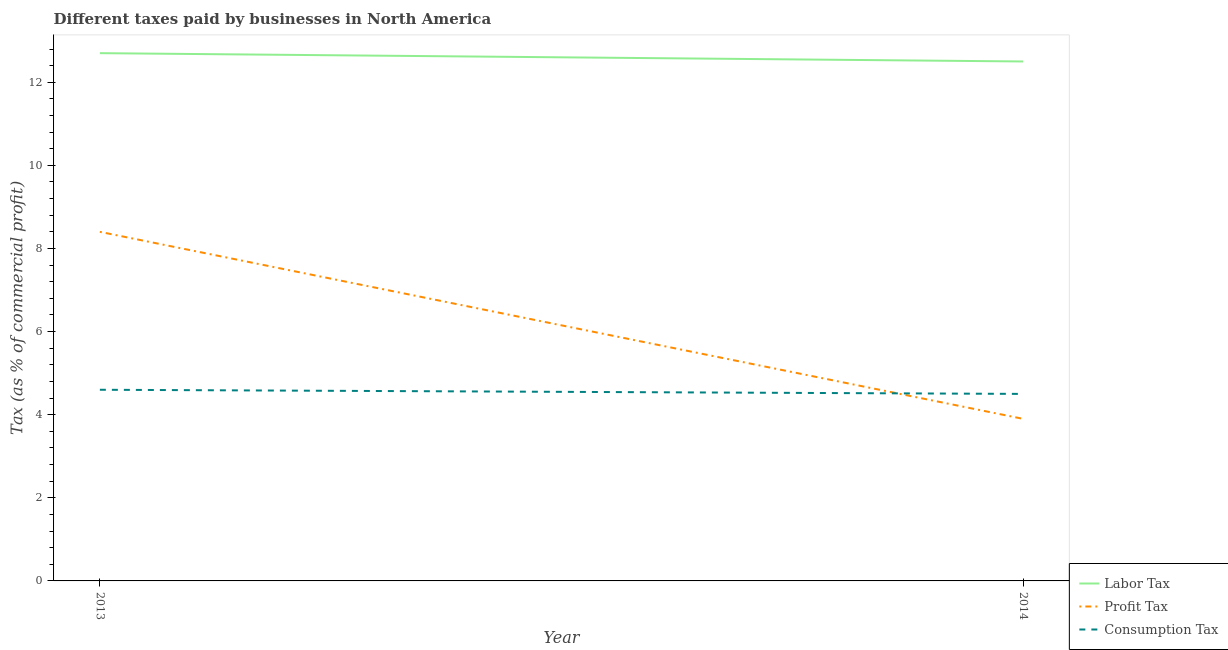How many different coloured lines are there?
Make the answer very short. 3. Does the line corresponding to percentage of profit tax intersect with the line corresponding to percentage of consumption tax?
Give a very brief answer. Yes. Is the number of lines equal to the number of legend labels?
Offer a very short reply. Yes. What is the percentage of profit tax in 2013?
Give a very brief answer. 8.4. In which year was the percentage of consumption tax maximum?
Give a very brief answer. 2013. In which year was the percentage of consumption tax minimum?
Provide a short and direct response. 2014. What is the total percentage of profit tax in the graph?
Your response must be concise. 12.3. What is the difference between the percentage of profit tax in 2013 and that in 2014?
Give a very brief answer. 4.5. What is the difference between the percentage of profit tax in 2013 and the percentage of labor tax in 2014?
Ensure brevity in your answer.  -4.1. What is the average percentage of labor tax per year?
Your response must be concise. 12.6. In the year 2014, what is the difference between the percentage of consumption tax and percentage of labor tax?
Give a very brief answer. -8. In how many years, is the percentage of profit tax greater than 1.6 %?
Ensure brevity in your answer.  2. What is the ratio of the percentage of labor tax in 2013 to that in 2014?
Provide a succinct answer. 1.02. In how many years, is the percentage of consumption tax greater than the average percentage of consumption tax taken over all years?
Offer a very short reply. 1. Is the percentage of profit tax strictly less than the percentage of consumption tax over the years?
Ensure brevity in your answer.  No. How many lines are there?
Your answer should be compact. 3. How many years are there in the graph?
Your answer should be compact. 2. What is the difference between two consecutive major ticks on the Y-axis?
Ensure brevity in your answer.  2. Where does the legend appear in the graph?
Offer a very short reply. Bottom right. How are the legend labels stacked?
Give a very brief answer. Vertical. What is the title of the graph?
Ensure brevity in your answer.  Different taxes paid by businesses in North America. Does "Negligence towards kids" appear as one of the legend labels in the graph?
Ensure brevity in your answer.  No. What is the label or title of the Y-axis?
Your answer should be very brief. Tax (as % of commercial profit). What is the Tax (as % of commercial profit) of Labor Tax in 2014?
Offer a very short reply. 12.5. What is the Tax (as % of commercial profit) in Profit Tax in 2014?
Offer a very short reply. 3.9. What is the Tax (as % of commercial profit) of Consumption Tax in 2014?
Offer a terse response. 4.5. Across all years, what is the maximum Tax (as % of commercial profit) of Labor Tax?
Give a very brief answer. 12.7. Across all years, what is the maximum Tax (as % of commercial profit) in Profit Tax?
Your response must be concise. 8.4. Across all years, what is the minimum Tax (as % of commercial profit) in Labor Tax?
Provide a succinct answer. 12.5. Across all years, what is the minimum Tax (as % of commercial profit) of Profit Tax?
Your answer should be very brief. 3.9. What is the total Tax (as % of commercial profit) of Labor Tax in the graph?
Your answer should be very brief. 25.2. What is the total Tax (as % of commercial profit) of Profit Tax in the graph?
Your response must be concise. 12.3. What is the total Tax (as % of commercial profit) of Consumption Tax in the graph?
Keep it short and to the point. 9.1. What is the difference between the Tax (as % of commercial profit) of Labor Tax in 2013 and the Tax (as % of commercial profit) of Profit Tax in 2014?
Make the answer very short. 8.8. What is the difference between the Tax (as % of commercial profit) in Labor Tax in 2013 and the Tax (as % of commercial profit) in Consumption Tax in 2014?
Keep it short and to the point. 8.2. What is the difference between the Tax (as % of commercial profit) of Profit Tax in 2013 and the Tax (as % of commercial profit) of Consumption Tax in 2014?
Give a very brief answer. 3.9. What is the average Tax (as % of commercial profit) of Labor Tax per year?
Provide a succinct answer. 12.6. What is the average Tax (as % of commercial profit) of Profit Tax per year?
Keep it short and to the point. 6.15. What is the average Tax (as % of commercial profit) of Consumption Tax per year?
Make the answer very short. 4.55. In the year 2013, what is the difference between the Tax (as % of commercial profit) of Labor Tax and Tax (as % of commercial profit) of Profit Tax?
Make the answer very short. 4.3. In the year 2013, what is the difference between the Tax (as % of commercial profit) of Labor Tax and Tax (as % of commercial profit) of Consumption Tax?
Give a very brief answer. 8.1. In the year 2013, what is the difference between the Tax (as % of commercial profit) in Profit Tax and Tax (as % of commercial profit) in Consumption Tax?
Provide a short and direct response. 3.8. In the year 2014, what is the difference between the Tax (as % of commercial profit) in Labor Tax and Tax (as % of commercial profit) in Profit Tax?
Make the answer very short. 8.6. What is the ratio of the Tax (as % of commercial profit) of Profit Tax in 2013 to that in 2014?
Make the answer very short. 2.15. What is the ratio of the Tax (as % of commercial profit) in Consumption Tax in 2013 to that in 2014?
Keep it short and to the point. 1.02. What is the difference between the highest and the second highest Tax (as % of commercial profit) in Labor Tax?
Offer a terse response. 0.2. What is the difference between the highest and the lowest Tax (as % of commercial profit) in Consumption Tax?
Give a very brief answer. 0.1. 